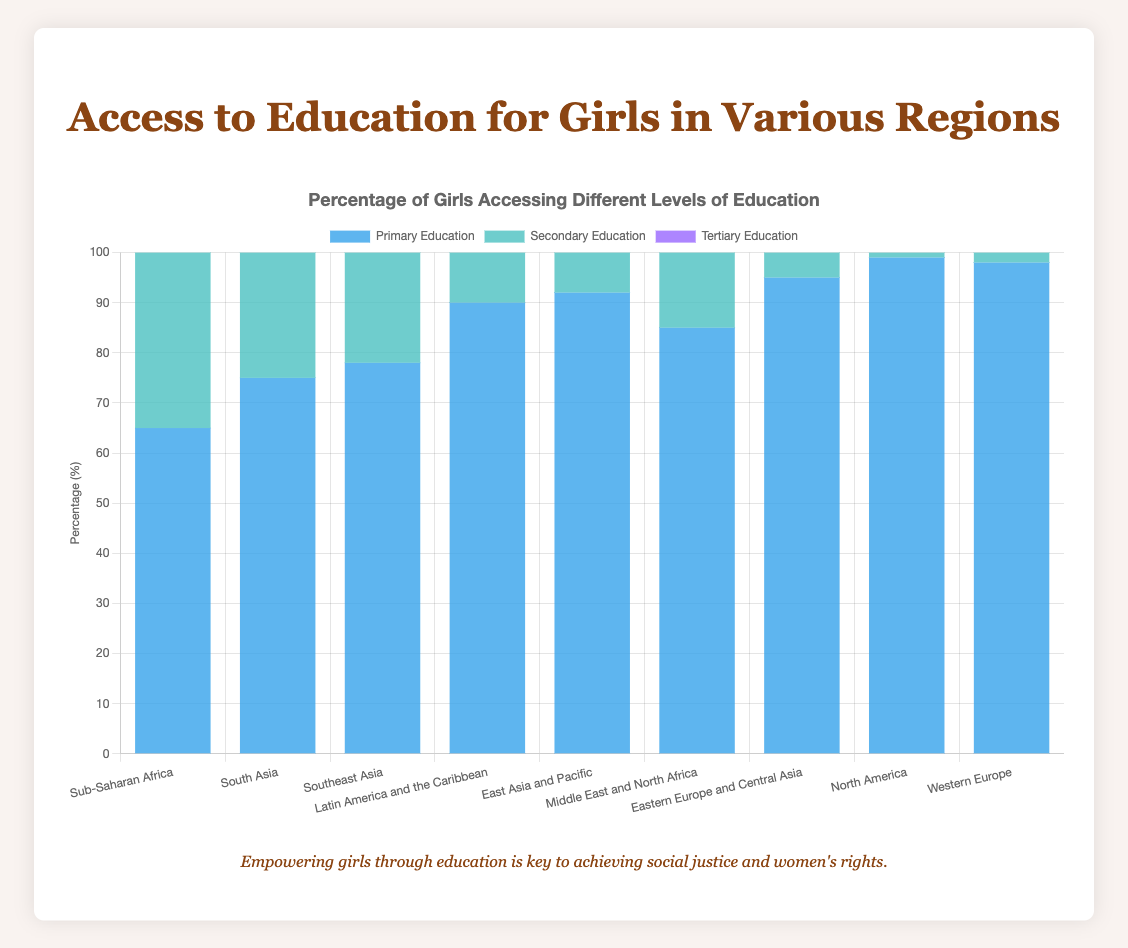Which region has the highest percentage of girls accessing primary education? By observing the heights of the blue bars, we see that North America has the highest percentage at 99%.
Answer: North America Which two regions have the smallest gap between primary and tertiary education access percentages? To find the smallest gap, subtract the tertiary percentage from the primary percentage for each region and compare. Sub-Saharan Africa (65 - 10 = 55) and South Asia (75 - 20 = 55) both have a gap of 55, which is the smallest.
Answer: Sub-Saharan Africa and South Asia Which region has the largest increase in access percentage from secondary to tertiary education? Subtract the secondary percentage from the tertiary percentage for each region. The largest positive value indicates the region with the largest increase. Eastern Europe and Central Asia has the largest increase (60 - 80 = -20) which suggests a significant difference.
Answer: Eastern Europe and Central Asia Compare the access to primary education between Latin America and the Caribbean and East Asia and Pacific. Which region has greater access? Refer to the blue bars for both regions: Latin America and the Caribbean is at 90%, while East Asia and Pacific is at 92%.
Answer: East Asia and Pacific What is the average percentage of girls accessing tertiary education in Western Europe and North America? Sum the tertiary percentages of Western Europe (68) and North America (70), then divide by 2: (68 + 70)/2 = 69.
Answer: 69% What percentage less is secondary education access in Sub-Saharan Africa compared to Western Europe? Subtract the secondary education percentage of Sub-Saharan Africa from that of Western Europe: 97 - 35 = 62%.
Answer: 62% If we sum the percentages of primary education access across all regions, what is the total? Add all the primary education percentages: 65 + 75 + 78 + 90 + 92 + 85 + 95 + 99 + 98 = 777%.
Answer: 777% Which region has the closest percentages for primary and secondary education access? Check the difference between primary and secondary percentages for each region: Eastern Europe and Central Asia (95 - 80 = 15%) has the closest.
Answer: Eastern Europe and Central Asia How much higher is the percentage of girls accessing secondary education in North America compared to South Asia? Subtract the secondary education percentage in South Asia from that in North America: 98 - 55 = 43%.
Answer: 43% Is access to tertiary education in the Middle East and North Africa higher or lower than in Southeast Asia? Compare the heights of the purple bars: Middle East and North Africa is at 30%, Southeast Asia is at 25%. Middle East and North Africa is higher.
Answer: Higher 